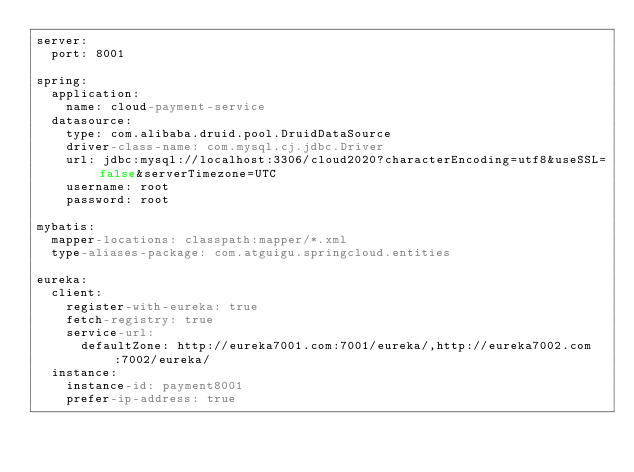<code> <loc_0><loc_0><loc_500><loc_500><_YAML_>server:
  port: 8001

spring:
  application:
    name: cloud-payment-service
  datasource:
    type: com.alibaba.druid.pool.DruidDataSource
    driver-class-name: com.mysql.cj.jdbc.Driver
    url: jdbc:mysql://localhost:3306/cloud2020?characterEncoding=utf8&useSSL=false&serverTimezone=UTC
    username: root
    password: root

mybatis:
  mapper-locations: classpath:mapper/*.xml
  type-aliases-package: com.atguigu.springcloud.entities

eureka:
  client:
    register-with-eureka: true
    fetch-registry: true
    service-url:
      defaultZone: http://eureka7001.com:7001/eureka/,http://eureka7002.com:7002/eureka/
  instance:
    instance-id: payment8001
    prefer-ip-address: true</code> 